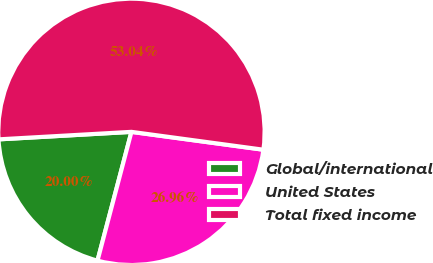Convert chart. <chart><loc_0><loc_0><loc_500><loc_500><pie_chart><fcel>Global/international<fcel>United States<fcel>Total fixed income<nl><fcel>20.0%<fcel>26.96%<fcel>53.04%<nl></chart> 